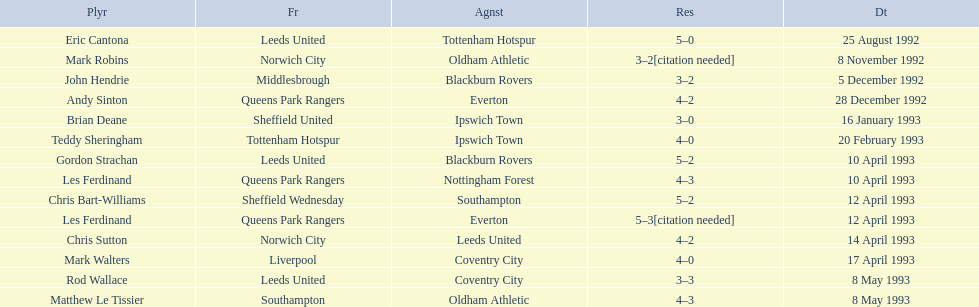Who are all the players? Eric Cantona, Mark Robins, John Hendrie, Andy Sinton, Brian Deane, Teddy Sheringham, Gordon Strachan, Les Ferdinand, Chris Bart-Williams, Les Ferdinand, Chris Sutton, Mark Walters, Rod Wallace, Matthew Le Tissier. What were their results? 5–0, 3–2[citation needed], 3–2, 4–2, 3–0, 4–0, 5–2, 4–3, 5–2, 5–3[citation needed], 4–2, 4–0, 3–3, 4–3. Which player tied with mark robins? John Hendrie. 